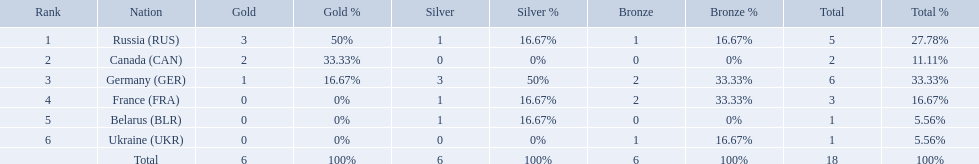Which countries had one or more gold medals? Russia (RUS), Canada (CAN), Germany (GER). Of these countries, which had at least one silver medal? Russia (RUS), Germany (GER). Of the remaining countries, who had more medals overall? Germany (GER). Could you parse the entire table? {'header': ['Rank', 'Nation', 'Gold', 'Gold %', 'Silver', 'Silver %', 'Bronze', 'Bronze %', 'Total', 'Total %'], 'rows': [['1', 'Russia\xa0(RUS)', '3', '50%', '1', '16.67%', '1', '16.67%', '5', '27.78%'], ['2', 'Canada\xa0(CAN)', '2', '33.33%', '0', '0%', '0', '0%', '2', '11.11%'], ['3', 'Germany\xa0(GER)', '1', '16.67%', '3', '50%', '2', '33.33%', '6', '33.33%'], ['4', 'France\xa0(FRA)', '0', '0%', '1', '16.67%', '2', '33.33%', '3', '16.67%'], ['5', 'Belarus\xa0(BLR)', '0', '0%', '1', '16.67%', '0', '0%', '1', '5.56%'], ['6', 'Ukraine\xa0(UKR)', '0', '0%', '0', '0%', '1', '16.67%', '1', '5.56%'], ['', 'Total', '6', '100%', '6', '100%', '6', '100%', '18', '100%']]} Which countries had one or more gold medals? Russia (RUS), Canada (CAN), Germany (GER). Of these countries, which had at least one silver medal? Russia (RUS), Germany (GER). Of the remaining countries, who had more medals overall? Germany (GER). Which countries competed in the 1995 biathlon? Russia (RUS), Canada (CAN), Germany (GER), France (FRA), Belarus (BLR), Ukraine (UKR). How many medals in total did they win? 5, 2, 6, 3, 1, 1. And which country had the most? Germany (GER). What were all the countries that won biathlon medals? Russia (RUS), Canada (CAN), Germany (GER), France (FRA), Belarus (BLR), Ukraine (UKR). What were their medal counts? 5, 2, 6, 3, 1, 1. Of these, which is the largest number of medals? 6. Which country won this number of medals? Germany (GER). What were all the countries that won biathlon medals? Russia (RUS), Canada (CAN), Germany (GER), France (FRA), Belarus (BLR), Ukraine (UKR). What were their medal counts? 5, 2, 6, 3, 1, 1. Of these, which is the largest number of medals? 6. Which country won this number of medals? Germany (GER). 